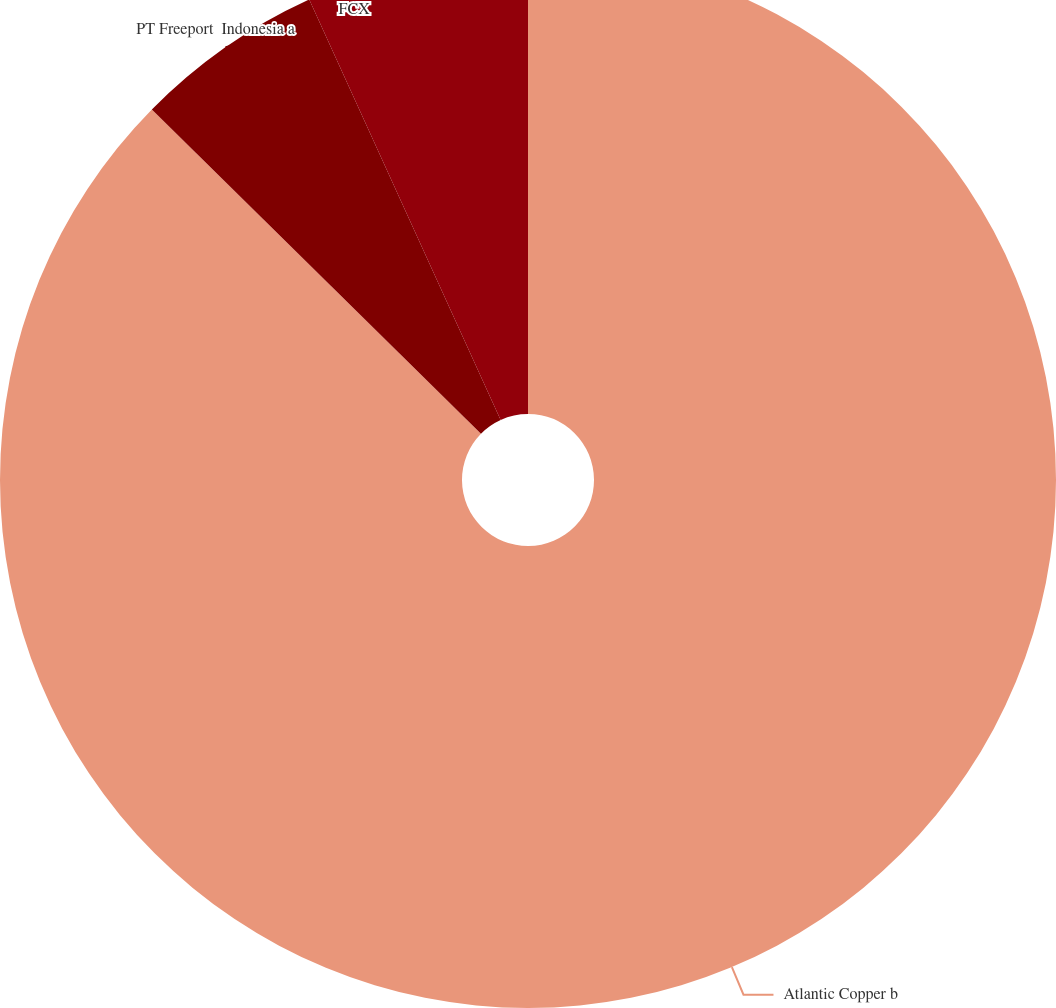Convert chart. <chart><loc_0><loc_0><loc_500><loc_500><pie_chart><fcel>Atlantic Copper b<fcel>PT Freeport  Indonesia a<fcel>FCX<nl><fcel>87.38%<fcel>5.82%<fcel>6.8%<nl></chart> 